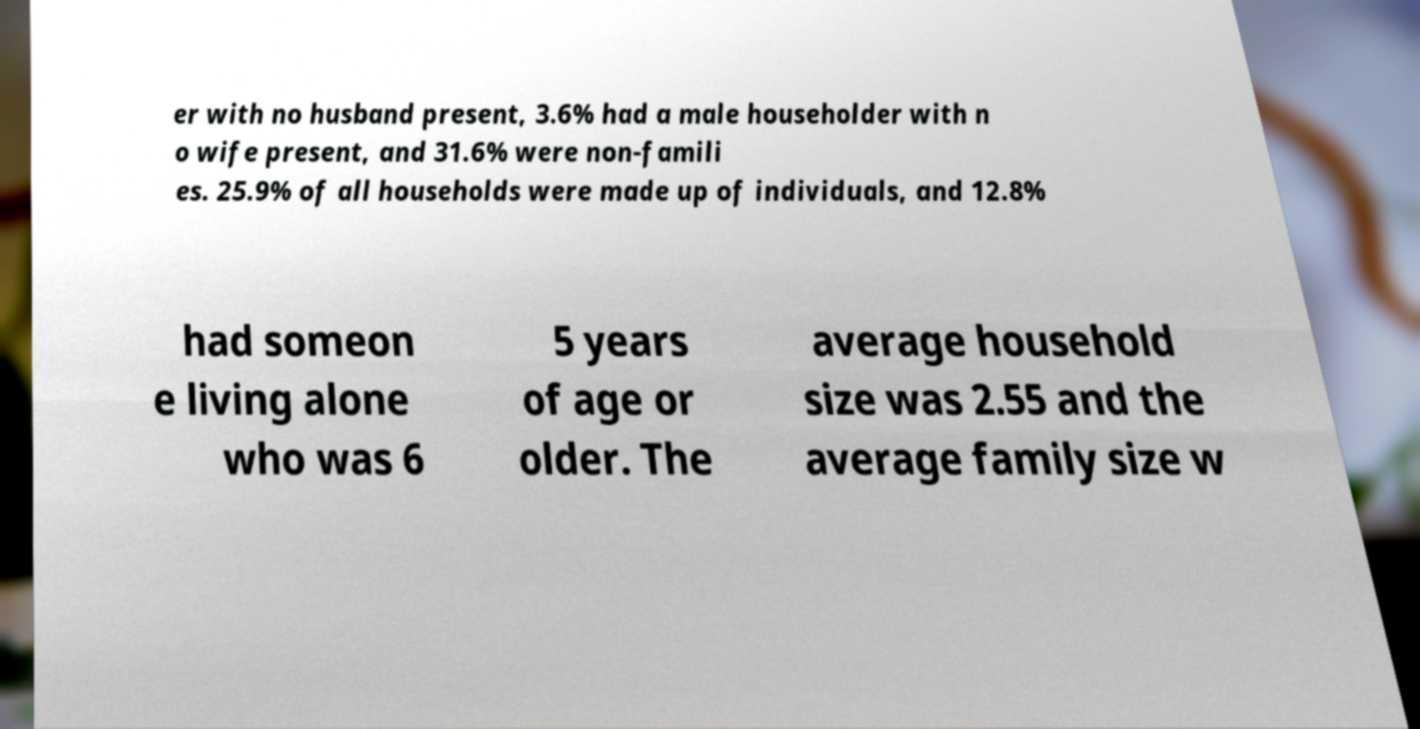Can you read and provide the text displayed in the image?This photo seems to have some interesting text. Can you extract and type it out for me? er with no husband present, 3.6% had a male householder with n o wife present, and 31.6% were non-famili es. 25.9% of all households were made up of individuals, and 12.8% had someon e living alone who was 6 5 years of age or older. The average household size was 2.55 and the average family size w 